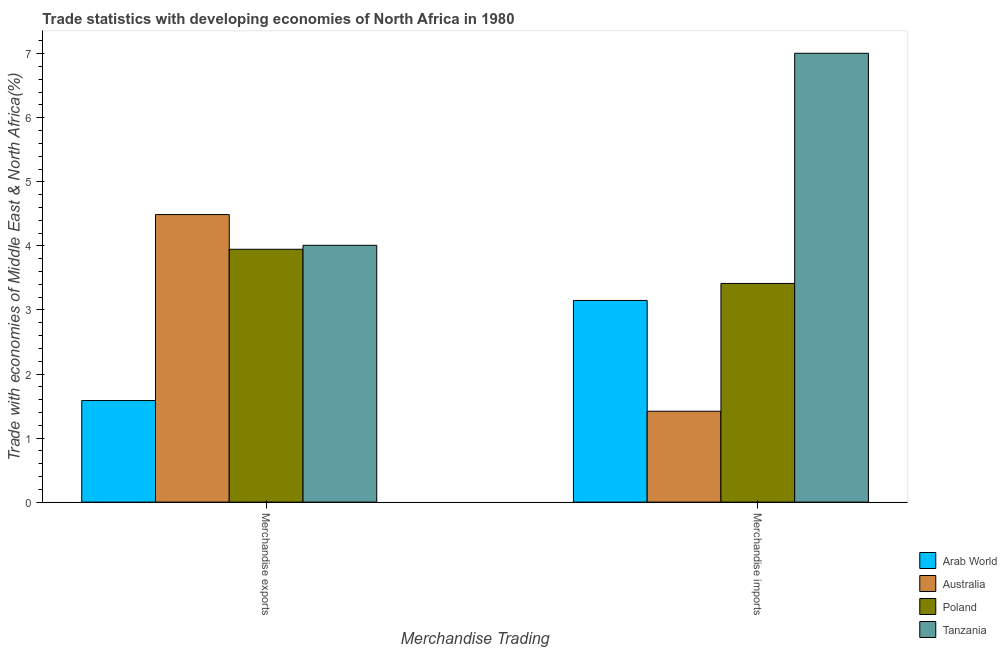How many different coloured bars are there?
Offer a very short reply. 4. How many groups of bars are there?
Your answer should be very brief. 2. How many bars are there on the 1st tick from the right?
Your response must be concise. 4. What is the merchandise exports in Tanzania?
Offer a terse response. 4.01. Across all countries, what is the maximum merchandise exports?
Provide a short and direct response. 4.49. Across all countries, what is the minimum merchandise imports?
Your answer should be very brief. 1.42. In which country was the merchandise imports maximum?
Your response must be concise. Tanzania. In which country was the merchandise imports minimum?
Offer a terse response. Australia. What is the total merchandise imports in the graph?
Provide a succinct answer. 14.99. What is the difference between the merchandise imports in Poland and that in Arab World?
Your answer should be compact. 0.27. What is the difference between the merchandise exports in Poland and the merchandise imports in Arab World?
Make the answer very short. 0.8. What is the average merchandise imports per country?
Offer a very short reply. 3.75. What is the difference between the merchandise imports and merchandise exports in Tanzania?
Provide a short and direct response. 3. What is the ratio of the merchandise exports in Poland to that in Tanzania?
Ensure brevity in your answer.  0.98. In how many countries, is the merchandise exports greater than the average merchandise exports taken over all countries?
Offer a very short reply. 3. What does the 2nd bar from the left in Merchandise imports represents?
Make the answer very short. Australia. What does the 1st bar from the right in Merchandise imports represents?
Provide a succinct answer. Tanzania. How many bars are there?
Your answer should be very brief. 8. Are all the bars in the graph horizontal?
Ensure brevity in your answer.  No. Are the values on the major ticks of Y-axis written in scientific E-notation?
Provide a short and direct response. No. What is the title of the graph?
Ensure brevity in your answer.  Trade statistics with developing economies of North Africa in 1980. What is the label or title of the X-axis?
Ensure brevity in your answer.  Merchandise Trading. What is the label or title of the Y-axis?
Your response must be concise. Trade with economies of Middle East & North Africa(%). What is the Trade with economies of Middle East & North Africa(%) of Arab World in Merchandise exports?
Provide a short and direct response. 1.59. What is the Trade with economies of Middle East & North Africa(%) in Australia in Merchandise exports?
Make the answer very short. 4.49. What is the Trade with economies of Middle East & North Africa(%) in Poland in Merchandise exports?
Your answer should be very brief. 3.95. What is the Trade with economies of Middle East & North Africa(%) of Tanzania in Merchandise exports?
Offer a very short reply. 4.01. What is the Trade with economies of Middle East & North Africa(%) in Arab World in Merchandise imports?
Provide a short and direct response. 3.15. What is the Trade with economies of Middle East & North Africa(%) in Australia in Merchandise imports?
Ensure brevity in your answer.  1.42. What is the Trade with economies of Middle East & North Africa(%) in Poland in Merchandise imports?
Offer a very short reply. 3.41. What is the Trade with economies of Middle East & North Africa(%) of Tanzania in Merchandise imports?
Provide a succinct answer. 7.01. Across all Merchandise Trading, what is the maximum Trade with economies of Middle East & North Africa(%) in Arab World?
Your answer should be compact. 3.15. Across all Merchandise Trading, what is the maximum Trade with economies of Middle East & North Africa(%) of Australia?
Make the answer very short. 4.49. Across all Merchandise Trading, what is the maximum Trade with economies of Middle East & North Africa(%) in Poland?
Provide a succinct answer. 3.95. Across all Merchandise Trading, what is the maximum Trade with economies of Middle East & North Africa(%) of Tanzania?
Your answer should be compact. 7.01. Across all Merchandise Trading, what is the minimum Trade with economies of Middle East & North Africa(%) of Arab World?
Provide a short and direct response. 1.59. Across all Merchandise Trading, what is the minimum Trade with economies of Middle East & North Africa(%) in Australia?
Your response must be concise. 1.42. Across all Merchandise Trading, what is the minimum Trade with economies of Middle East & North Africa(%) of Poland?
Provide a succinct answer. 3.41. Across all Merchandise Trading, what is the minimum Trade with economies of Middle East & North Africa(%) of Tanzania?
Make the answer very short. 4.01. What is the total Trade with economies of Middle East & North Africa(%) in Arab World in the graph?
Keep it short and to the point. 4.73. What is the total Trade with economies of Middle East & North Africa(%) in Australia in the graph?
Offer a terse response. 5.91. What is the total Trade with economies of Middle East & North Africa(%) in Poland in the graph?
Keep it short and to the point. 7.36. What is the total Trade with economies of Middle East & North Africa(%) in Tanzania in the graph?
Offer a terse response. 11.02. What is the difference between the Trade with economies of Middle East & North Africa(%) of Arab World in Merchandise exports and that in Merchandise imports?
Offer a very short reply. -1.56. What is the difference between the Trade with economies of Middle East & North Africa(%) in Australia in Merchandise exports and that in Merchandise imports?
Keep it short and to the point. 3.07. What is the difference between the Trade with economies of Middle East & North Africa(%) of Poland in Merchandise exports and that in Merchandise imports?
Give a very brief answer. 0.53. What is the difference between the Trade with economies of Middle East & North Africa(%) of Tanzania in Merchandise exports and that in Merchandise imports?
Offer a very short reply. -3. What is the difference between the Trade with economies of Middle East & North Africa(%) of Arab World in Merchandise exports and the Trade with economies of Middle East & North Africa(%) of Australia in Merchandise imports?
Offer a very short reply. 0.17. What is the difference between the Trade with economies of Middle East & North Africa(%) of Arab World in Merchandise exports and the Trade with economies of Middle East & North Africa(%) of Poland in Merchandise imports?
Make the answer very short. -1.83. What is the difference between the Trade with economies of Middle East & North Africa(%) in Arab World in Merchandise exports and the Trade with economies of Middle East & North Africa(%) in Tanzania in Merchandise imports?
Keep it short and to the point. -5.42. What is the difference between the Trade with economies of Middle East & North Africa(%) in Australia in Merchandise exports and the Trade with economies of Middle East & North Africa(%) in Poland in Merchandise imports?
Your answer should be very brief. 1.08. What is the difference between the Trade with economies of Middle East & North Africa(%) of Australia in Merchandise exports and the Trade with economies of Middle East & North Africa(%) of Tanzania in Merchandise imports?
Offer a terse response. -2.52. What is the difference between the Trade with economies of Middle East & North Africa(%) in Poland in Merchandise exports and the Trade with economies of Middle East & North Africa(%) in Tanzania in Merchandise imports?
Keep it short and to the point. -3.06. What is the average Trade with economies of Middle East & North Africa(%) of Arab World per Merchandise Trading?
Offer a terse response. 2.37. What is the average Trade with economies of Middle East & North Africa(%) of Australia per Merchandise Trading?
Keep it short and to the point. 2.95. What is the average Trade with economies of Middle East & North Africa(%) in Poland per Merchandise Trading?
Make the answer very short. 3.68. What is the average Trade with economies of Middle East & North Africa(%) in Tanzania per Merchandise Trading?
Provide a succinct answer. 5.51. What is the difference between the Trade with economies of Middle East & North Africa(%) in Arab World and Trade with economies of Middle East & North Africa(%) in Australia in Merchandise exports?
Keep it short and to the point. -2.9. What is the difference between the Trade with economies of Middle East & North Africa(%) of Arab World and Trade with economies of Middle East & North Africa(%) of Poland in Merchandise exports?
Ensure brevity in your answer.  -2.36. What is the difference between the Trade with economies of Middle East & North Africa(%) of Arab World and Trade with economies of Middle East & North Africa(%) of Tanzania in Merchandise exports?
Offer a very short reply. -2.42. What is the difference between the Trade with economies of Middle East & North Africa(%) in Australia and Trade with economies of Middle East & North Africa(%) in Poland in Merchandise exports?
Keep it short and to the point. 0.54. What is the difference between the Trade with economies of Middle East & North Africa(%) of Australia and Trade with economies of Middle East & North Africa(%) of Tanzania in Merchandise exports?
Make the answer very short. 0.48. What is the difference between the Trade with economies of Middle East & North Africa(%) of Poland and Trade with economies of Middle East & North Africa(%) of Tanzania in Merchandise exports?
Your response must be concise. -0.06. What is the difference between the Trade with economies of Middle East & North Africa(%) in Arab World and Trade with economies of Middle East & North Africa(%) in Australia in Merchandise imports?
Give a very brief answer. 1.73. What is the difference between the Trade with economies of Middle East & North Africa(%) in Arab World and Trade with economies of Middle East & North Africa(%) in Poland in Merchandise imports?
Your answer should be compact. -0.27. What is the difference between the Trade with economies of Middle East & North Africa(%) of Arab World and Trade with economies of Middle East & North Africa(%) of Tanzania in Merchandise imports?
Keep it short and to the point. -3.86. What is the difference between the Trade with economies of Middle East & North Africa(%) of Australia and Trade with economies of Middle East & North Africa(%) of Poland in Merchandise imports?
Make the answer very short. -2. What is the difference between the Trade with economies of Middle East & North Africa(%) of Australia and Trade with economies of Middle East & North Africa(%) of Tanzania in Merchandise imports?
Keep it short and to the point. -5.59. What is the difference between the Trade with economies of Middle East & North Africa(%) of Poland and Trade with economies of Middle East & North Africa(%) of Tanzania in Merchandise imports?
Ensure brevity in your answer.  -3.59. What is the ratio of the Trade with economies of Middle East & North Africa(%) in Arab World in Merchandise exports to that in Merchandise imports?
Offer a very short reply. 0.5. What is the ratio of the Trade with economies of Middle East & North Africa(%) of Australia in Merchandise exports to that in Merchandise imports?
Provide a succinct answer. 3.16. What is the ratio of the Trade with economies of Middle East & North Africa(%) of Poland in Merchandise exports to that in Merchandise imports?
Give a very brief answer. 1.16. What is the ratio of the Trade with economies of Middle East & North Africa(%) of Tanzania in Merchandise exports to that in Merchandise imports?
Give a very brief answer. 0.57. What is the difference between the highest and the second highest Trade with economies of Middle East & North Africa(%) of Arab World?
Your answer should be very brief. 1.56. What is the difference between the highest and the second highest Trade with economies of Middle East & North Africa(%) in Australia?
Your answer should be compact. 3.07. What is the difference between the highest and the second highest Trade with economies of Middle East & North Africa(%) of Poland?
Provide a short and direct response. 0.53. What is the difference between the highest and the second highest Trade with economies of Middle East & North Africa(%) of Tanzania?
Provide a succinct answer. 3. What is the difference between the highest and the lowest Trade with economies of Middle East & North Africa(%) of Arab World?
Your response must be concise. 1.56. What is the difference between the highest and the lowest Trade with economies of Middle East & North Africa(%) of Australia?
Keep it short and to the point. 3.07. What is the difference between the highest and the lowest Trade with economies of Middle East & North Africa(%) of Poland?
Your response must be concise. 0.53. What is the difference between the highest and the lowest Trade with economies of Middle East & North Africa(%) of Tanzania?
Offer a terse response. 3. 